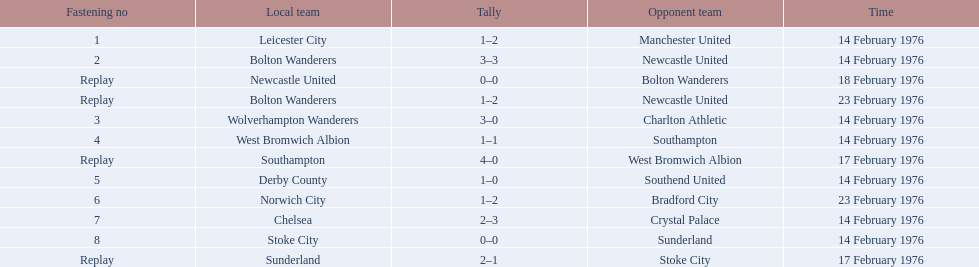What is the game at the top of the table? 1. Who is the home team for this game? Leicester City. 